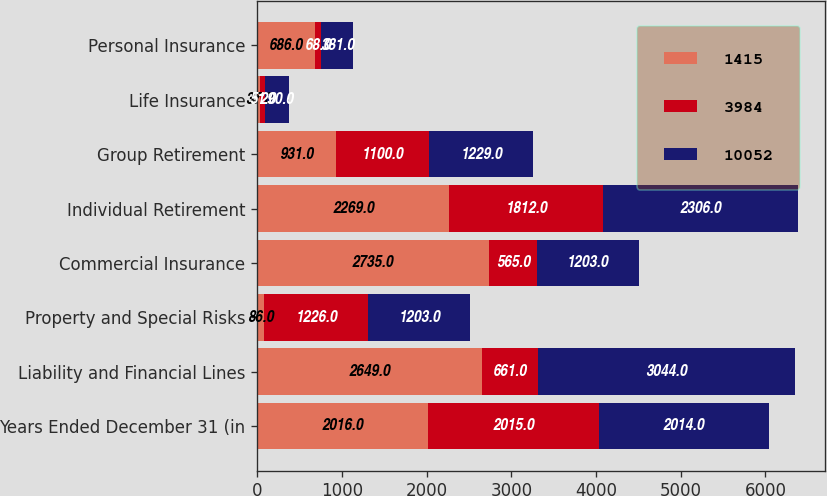Convert chart to OTSL. <chart><loc_0><loc_0><loc_500><loc_500><stacked_bar_chart><ecel><fcel>Years Ended December 31 (in<fcel>Liability and Financial Lines<fcel>Property and Special Risks<fcel>Commercial Insurance<fcel>Individual Retirement<fcel>Group Retirement<fcel>Life Insurance<fcel>Personal Insurance<nl><fcel>1415<fcel>2016<fcel>2649<fcel>86<fcel>2735<fcel>2269<fcel>931<fcel>37<fcel>686<nl><fcel>3984<fcel>2015<fcel>661<fcel>1226<fcel>565<fcel>1812<fcel>1100<fcel>51<fcel>68<nl><fcel>10052<fcel>2014<fcel>3044<fcel>1203<fcel>1203<fcel>2306<fcel>1229<fcel>290<fcel>381<nl></chart> 